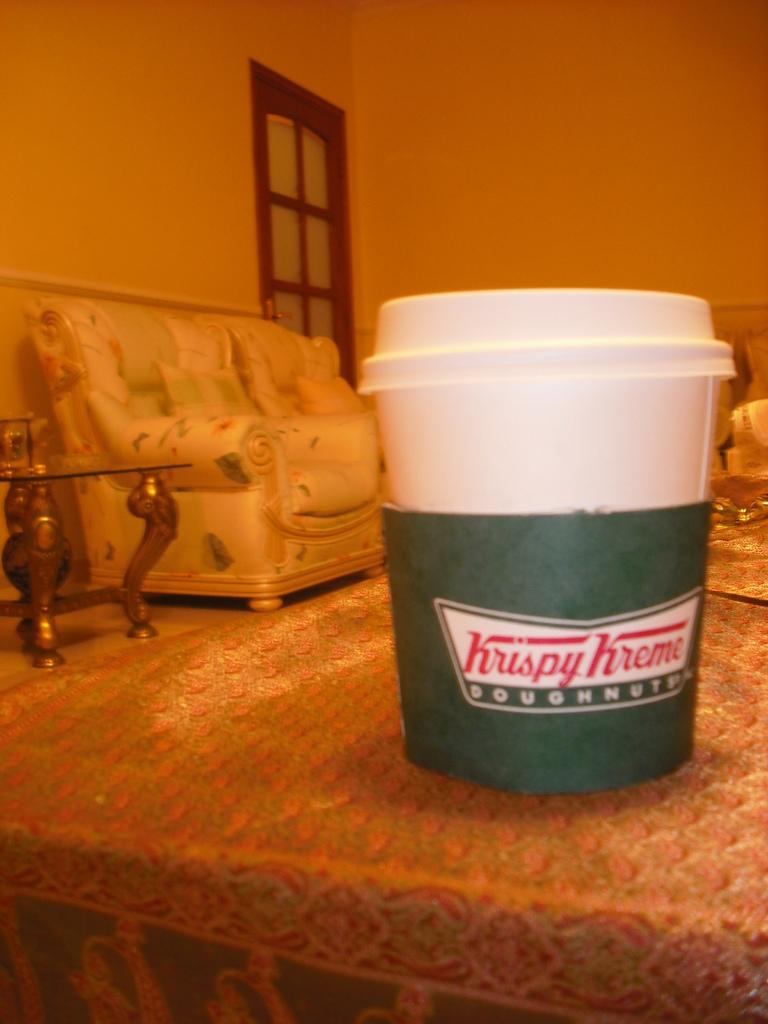What object is on the table in the image? There is a cup on the table in the image. What furniture is on the left side of the image? There is a sofa and a table on the left side of the image. What can be seen in the background of the image? There is a wall with a window in the background of the image. Can you see any spark coming from the office in the image? There is no office or spark present in the image. Is there a lake visible through the window in the image? There is no lake visible through the window in the image; only a wall is present in the background. 